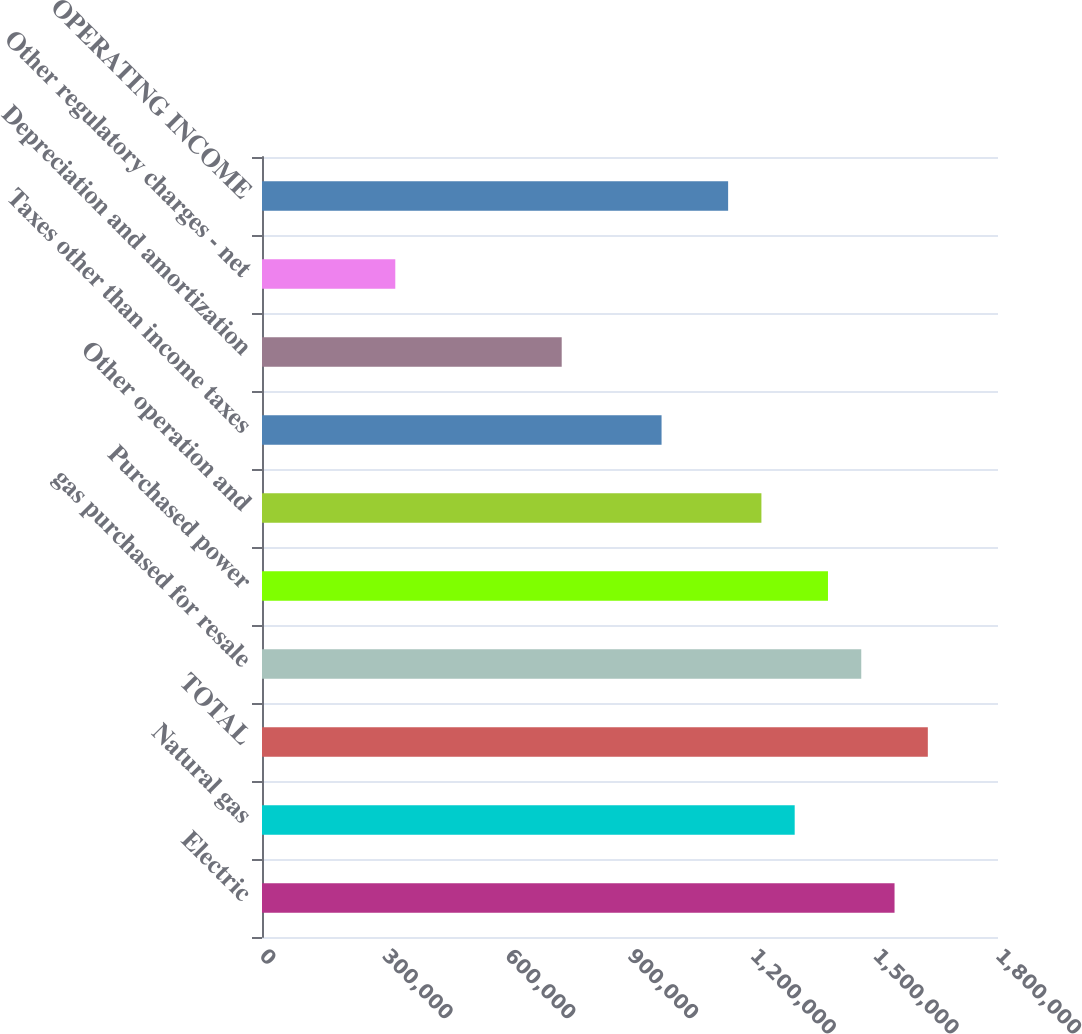Convert chart. <chart><loc_0><loc_0><loc_500><loc_500><bar_chart><fcel>Electric<fcel>Natural gas<fcel>TOTAL<fcel>gas purchased for resale<fcel>Purchased power<fcel>Other operation and<fcel>Taxes other than income taxes<fcel>Depreciation and amortization<fcel>Other regulatory charges - net<fcel>OPERATING INCOME<nl><fcel>1.54698e+06<fcel>1.30278e+06<fcel>1.62838e+06<fcel>1.46558e+06<fcel>1.38418e+06<fcel>1.22138e+06<fcel>977182<fcel>732984<fcel>325986<fcel>1.13998e+06<nl></chart> 